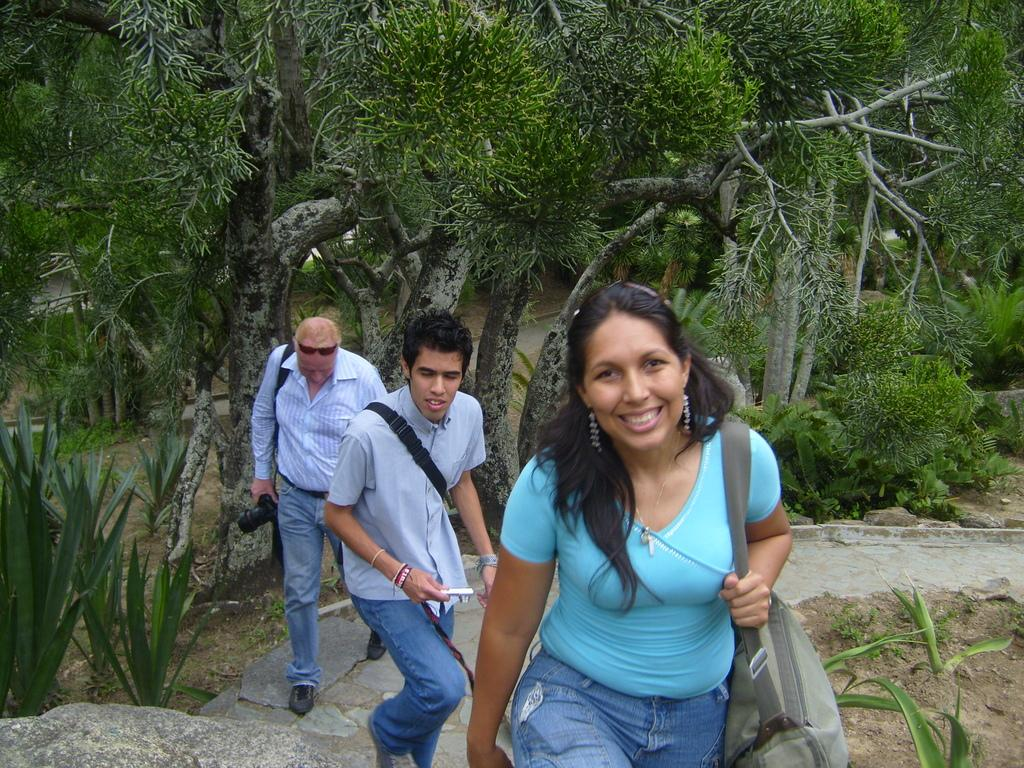How many people are in the image? There are two men and a woman in the image. What is the woman holding in the image? The woman is carrying a bag. What is one of the men doing in the image? One man is holding a camera. What can be seen in the background of the image? There are trees in the background of the image. What type of basin is visible in the image? There is no basin present in the image. Can you see a chessboard in the image? There is no chessboard present in the image. 